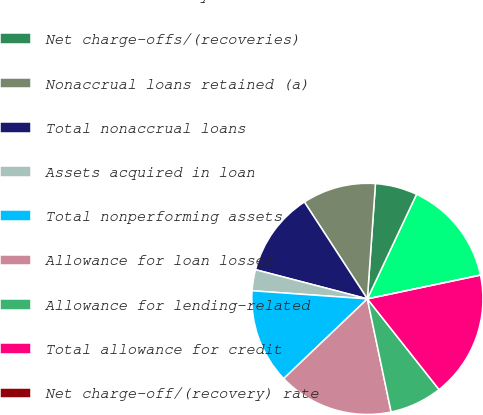Convert chart to OTSL. <chart><loc_0><loc_0><loc_500><loc_500><pie_chart><fcel>As of or for the year ended<fcel>Net charge-offs/(recoveries)<fcel>Nonaccrual loans retained (a)<fcel>Total nonaccrual loans<fcel>Assets acquired in loan<fcel>Total nonperforming assets<fcel>Allowance for loan losses<fcel>Allowance for lending-related<fcel>Total allowance for credit<fcel>Net charge-off/(recovery) rate<nl><fcel>14.71%<fcel>5.88%<fcel>10.29%<fcel>11.76%<fcel>2.94%<fcel>13.24%<fcel>16.18%<fcel>7.35%<fcel>17.65%<fcel>0.0%<nl></chart> 